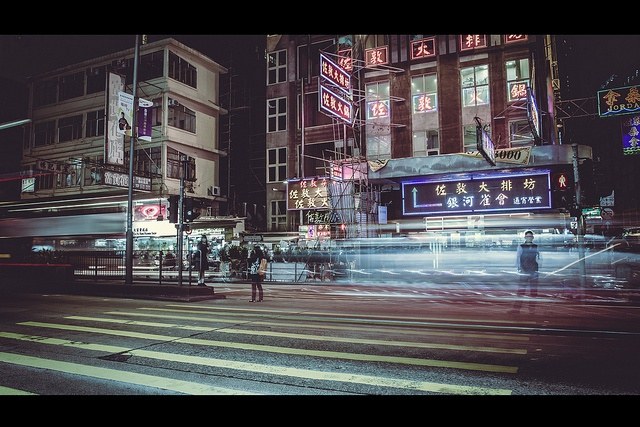Describe the objects in this image and their specific colors. I can see people in black, gray, and purple tones, traffic light in black, maroon, gray, and navy tones, people in black, gray, and darkgray tones, people in black, gray, and darkgray tones, and traffic light in black and gray tones in this image. 